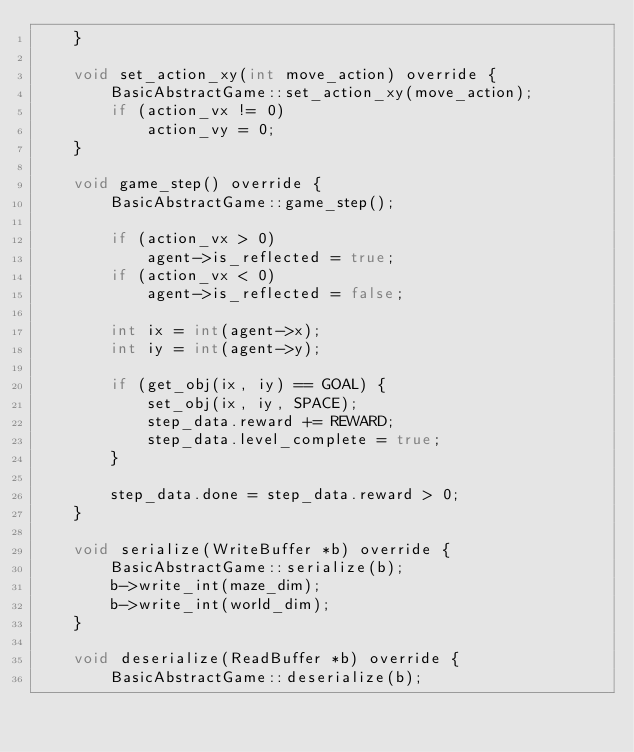<code> <loc_0><loc_0><loc_500><loc_500><_C++_>    }

    void set_action_xy(int move_action) override {
        BasicAbstractGame::set_action_xy(move_action);
        if (action_vx != 0)
            action_vy = 0;
    }

    void game_step() override {
        BasicAbstractGame::game_step();

        if (action_vx > 0)
            agent->is_reflected = true;
        if (action_vx < 0)
            agent->is_reflected = false;

        int ix = int(agent->x);
        int iy = int(agent->y);

        if (get_obj(ix, iy) == GOAL) {
            set_obj(ix, iy, SPACE);
            step_data.reward += REWARD;
            step_data.level_complete = true;
        }

        step_data.done = step_data.reward > 0;
    }

    void serialize(WriteBuffer *b) override {
        BasicAbstractGame::serialize(b);
        b->write_int(maze_dim);
        b->write_int(world_dim);
    }

    void deserialize(ReadBuffer *b) override {
        BasicAbstractGame::deserialize(b);</code> 